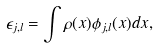Convert formula to latex. <formula><loc_0><loc_0><loc_500><loc_500>\epsilon _ { j , l } = \int \rho ( { x } ) \phi _ { j , l } ( { x } ) d { x } ,</formula> 